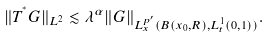<formula> <loc_0><loc_0><loc_500><loc_500>\| T ^ { ^ { * } } G \| _ { L ^ { 2 } } \lesssim \lambda ^ { \alpha } \| G \| _ { L _ { x } ^ { p ^ { \prime } } ( B ( x _ { 0 } , R ) , L _ { t } ^ { 1 } ( 0 , 1 ) ) } .</formula> 